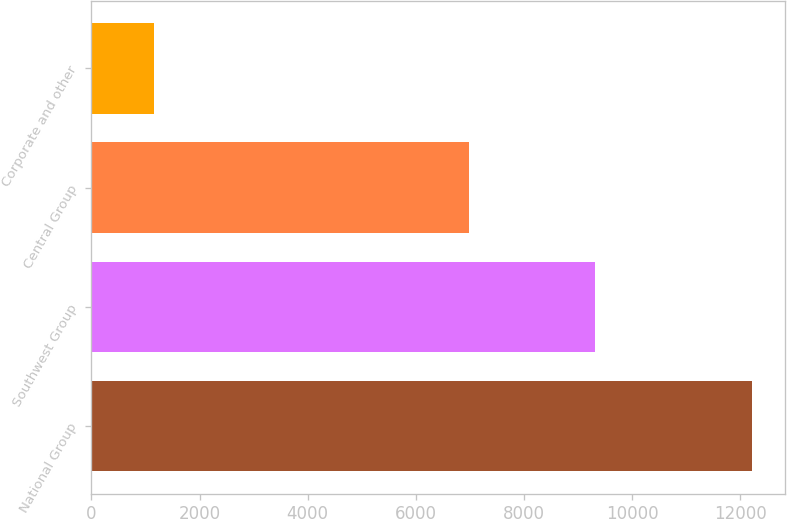Convert chart. <chart><loc_0><loc_0><loc_500><loc_500><bar_chart><fcel>National Group<fcel>Southwest Group<fcel>Central Group<fcel>Corporate and other<nl><fcel>12224<fcel>9311<fcel>6982<fcel>1165<nl></chart> 